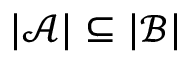Convert formula to latex. <formula><loc_0><loc_0><loc_500><loc_500>| { \mathcal { A } } | \subseteq | { \mathcal { B } } |</formula> 